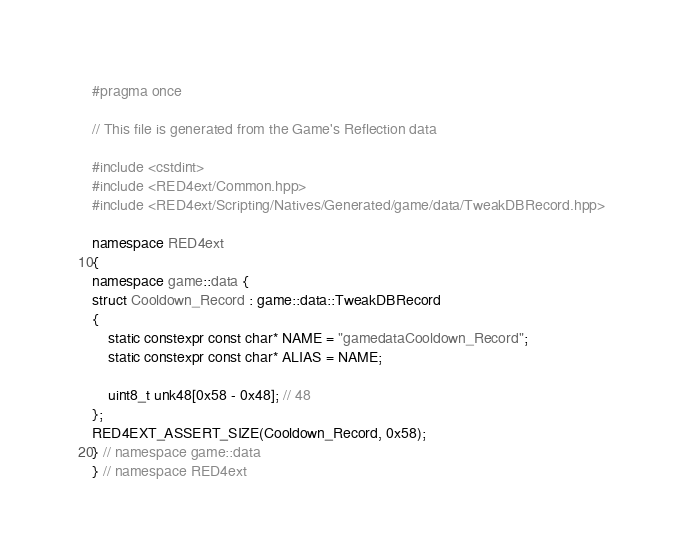Convert code to text. <code><loc_0><loc_0><loc_500><loc_500><_C++_>#pragma once

// This file is generated from the Game's Reflection data

#include <cstdint>
#include <RED4ext/Common.hpp>
#include <RED4ext/Scripting/Natives/Generated/game/data/TweakDBRecord.hpp>

namespace RED4ext
{
namespace game::data { 
struct Cooldown_Record : game::data::TweakDBRecord
{
    static constexpr const char* NAME = "gamedataCooldown_Record";
    static constexpr const char* ALIAS = NAME;

    uint8_t unk48[0x58 - 0x48]; // 48
};
RED4EXT_ASSERT_SIZE(Cooldown_Record, 0x58);
} // namespace game::data
} // namespace RED4ext
</code> 